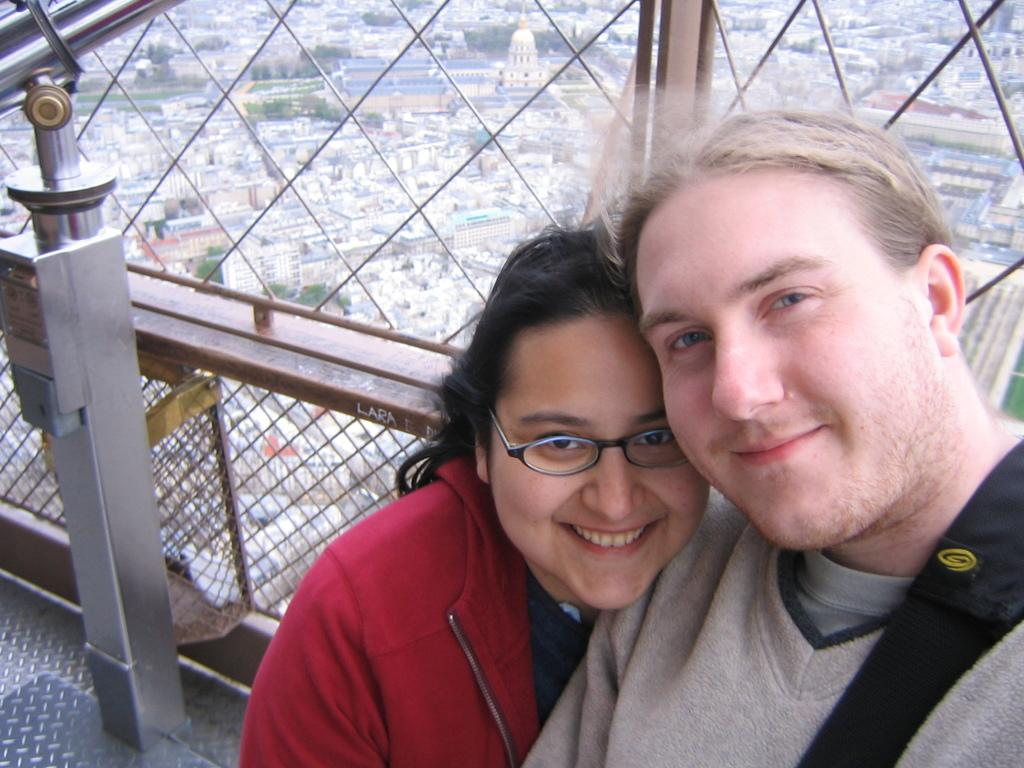How many people are in the image? There are two persons standing in the bottom right corner of the image. What is the facial expression of the persons in the image? The persons are smiling. What is located behind the persons in the image? There is fencing behind the persons. What can be seen through the fencing in the image? Trees and buildings are visible through the fencing. What type of sweater is the person in the image wearing? There is no information about clothing in the image, so it cannot be determined if the person is wearing a sweater or any other type of clothing. 